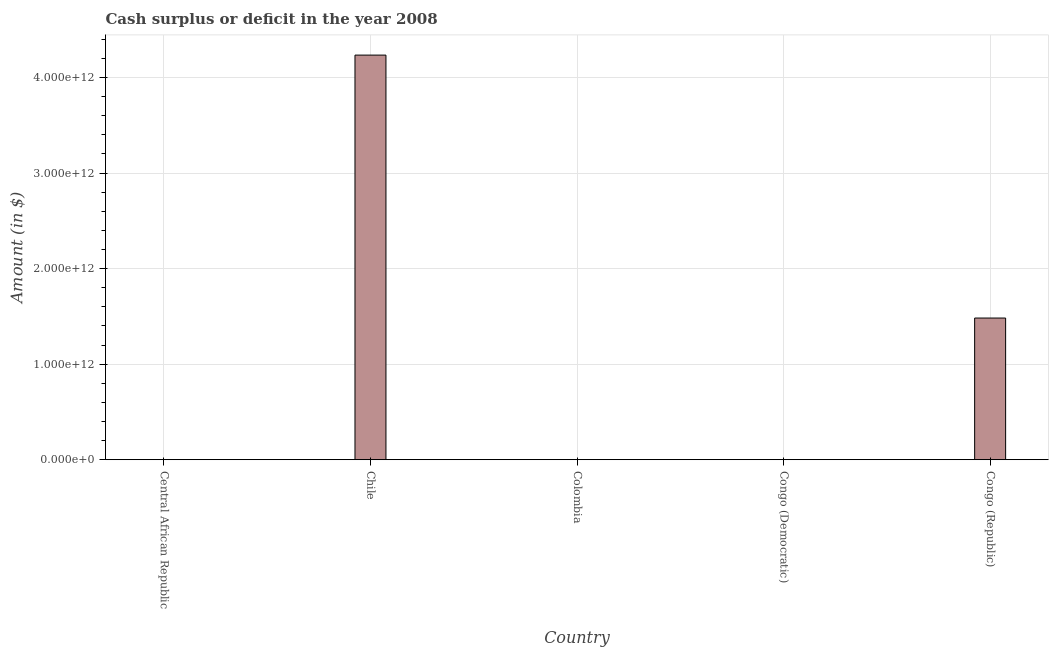Does the graph contain any zero values?
Your response must be concise. Yes. Does the graph contain grids?
Your answer should be very brief. Yes. What is the title of the graph?
Keep it short and to the point. Cash surplus or deficit in the year 2008. What is the label or title of the Y-axis?
Ensure brevity in your answer.  Amount (in $). Across all countries, what is the maximum cash surplus or deficit?
Offer a terse response. 4.23e+12. In which country was the cash surplus or deficit maximum?
Your answer should be very brief. Chile. What is the sum of the cash surplus or deficit?
Give a very brief answer. 5.72e+12. What is the difference between the cash surplus or deficit in Chile and Congo (Republic)?
Provide a short and direct response. 2.75e+12. What is the average cash surplus or deficit per country?
Offer a terse response. 1.14e+12. What is the median cash surplus or deficit?
Make the answer very short. 0. In how many countries, is the cash surplus or deficit greater than 3400000000000 $?
Give a very brief answer. 1. What is the ratio of the cash surplus or deficit in Chile to that in Congo (Republic)?
Offer a terse response. 2.86. Is the difference between the cash surplus or deficit in Chile and Congo (Republic) greater than the difference between any two countries?
Offer a terse response. No. What is the difference between the highest and the lowest cash surplus or deficit?
Provide a succinct answer. 4.23e+12. In how many countries, is the cash surplus or deficit greater than the average cash surplus or deficit taken over all countries?
Make the answer very short. 2. How many bars are there?
Your response must be concise. 2. Are all the bars in the graph horizontal?
Your answer should be compact. No. How many countries are there in the graph?
Your answer should be very brief. 5. What is the difference between two consecutive major ticks on the Y-axis?
Your answer should be compact. 1.00e+12. Are the values on the major ticks of Y-axis written in scientific E-notation?
Your response must be concise. Yes. What is the Amount (in $) of Chile?
Provide a succinct answer. 4.23e+12. What is the Amount (in $) in Colombia?
Keep it short and to the point. 0. What is the Amount (in $) of Congo (Republic)?
Give a very brief answer. 1.48e+12. What is the difference between the Amount (in $) in Chile and Congo (Republic)?
Your response must be concise. 2.75e+12. What is the ratio of the Amount (in $) in Chile to that in Congo (Republic)?
Your answer should be very brief. 2.86. 